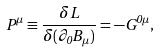<formula> <loc_0><loc_0><loc_500><loc_500>P ^ { \mu } \equiv \frac { \delta L } { \delta ( \partial _ { 0 } B _ { \mu } ) } = - G ^ { 0 \mu } ,</formula> 